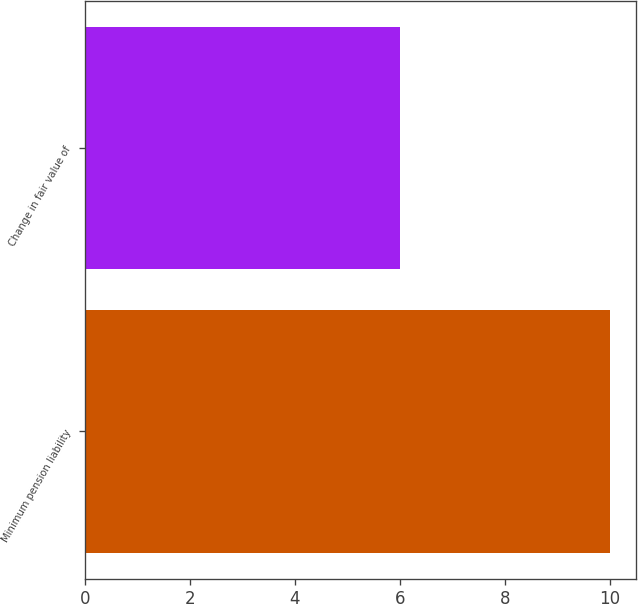Convert chart. <chart><loc_0><loc_0><loc_500><loc_500><bar_chart><fcel>Minimum pension liability<fcel>Change in fair value of<nl><fcel>10<fcel>6<nl></chart> 